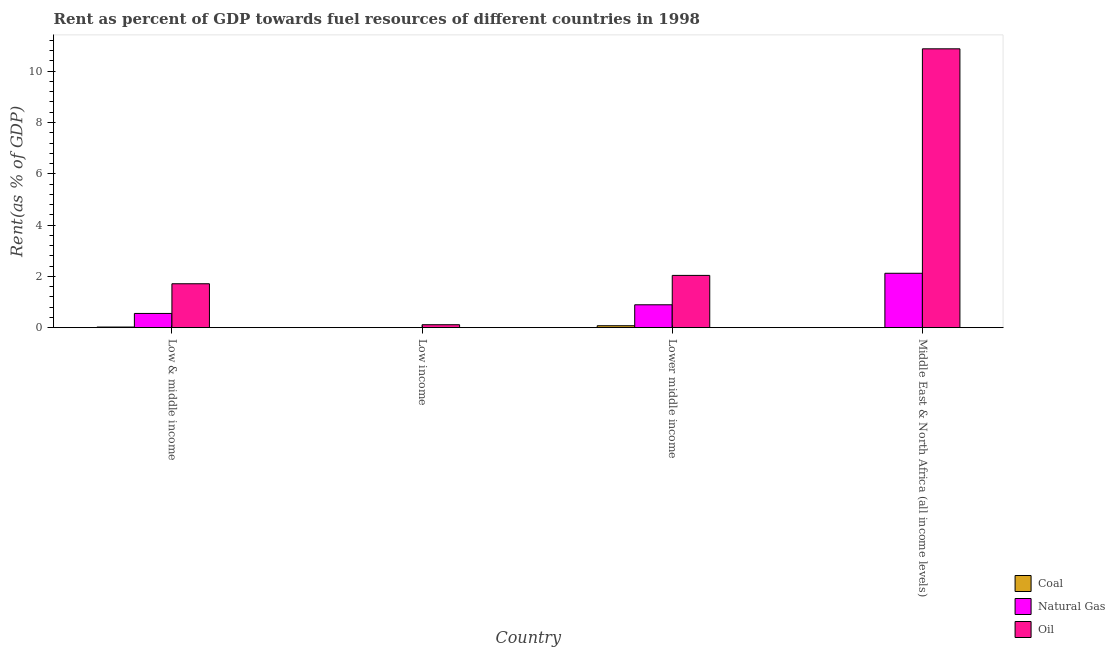How many groups of bars are there?
Your answer should be very brief. 4. How many bars are there on the 2nd tick from the left?
Your response must be concise. 3. How many bars are there on the 1st tick from the right?
Offer a terse response. 3. What is the label of the 1st group of bars from the left?
Provide a short and direct response. Low & middle income. What is the rent towards coal in Low income?
Your answer should be very brief. 3.540870127657071e-5. Across all countries, what is the maximum rent towards oil?
Ensure brevity in your answer.  10.87. Across all countries, what is the minimum rent towards natural gas?
Your response must be concise. 4.30567063288371e-5. In which country was the rent towards coal maximum?
Ensure brevity in your answer.  Lower middle income. What is the total rent towards natural gas in the graph?
Ensure brevity in your answer.  3.57. What is the difference between the rent towards oil in Low income and that in Middle East & North Africa (all income levels)?
Provide a succinct answer. -10.76. What is the difference between the rent towards natural gas in Low income and the rent towards coal in Low & middle income?
Your answer should be very brief. -0.02. What is the average rent towards natural gas per country?
Offer a very short reply. 0.89. What is the difference between the rent towards natural gas and rent towards oil in Middle East & North Africa (all income levels)?
Your response must be concise. -8.75. What is the ratio of the rent towards natural gas in Low & middle income to that in Low income?
Your response must be concise. 1.29e+04. Is the rent towards oil in Low income less than that in Lower middle income?
Your answer should be compact. Yes. Is the difference between the rent towards natural gas in Low & middle income and Low income greater than the difference between the rent towards coal in Low & middle income and Low income?
Ensure brevity in your answer.  Yes. What is the difference between the highest and the second highest rent towards natural gas?
Provide a short and direct response. 1.23. What is the difference between the highest and the lowest rent towards natural gas?
Provide a succinct answer. 2.12. What does the 2nd bar from the left in Lower middle income represents?
Ensure brevity in your answer.  Natural Gas. What does the 3rd bar from the right in Low income represents?
Give a very brief answer. Coal. Are the values on the major ticks of Y-axis written in scientific E-notation?
Your response must be concise. No. Does the graph contain any zero values?
Your answer should be very brief. No. Does the graph contain grids?
Give a very brief answer. No. Where does the legend appear in the graph?
Ensure brevity in your answer.  Bottom right. What is the title of the graph?
Your response must be concise. Rent as percent of GDP towards fuel resources of different countries in 1998. Does "Gaseous fuel" appear as one of the legend labels in the graph?
Ensure brevity in your answer.  No. What is the label or title of the Y-axis?
Offer a very short reply. Rent(as % of GDP). What is the Rent(as % of GDP) of Coal in Low & middle income?
Provide a short and direct response. 0.02. What is the Rent(as % of GDP) of Natural Gas in Low & middle income?
Provide a succinct answer. 0.55. What is the Rent(as % of GDP) in Oil in Low & middle income?
Ensure brevity in your answer.  1.71. What is the Rent(as % of GDP) in Coal in Low income?
Your response must be concise. 3.540870127657071e-5. What is the Rent(as % of GDP) in Natural Gas in Low income?
Your response must be concise. 4.30567063288371e-5. What is the Rent(as % of GDP) in Oil in Low income?
Give a very brief answer. 0.11. What is the Rent(as % of GDP) of Coal in Lower middle income?
Your answer should be compact. 0.08. What is the Rent(as % of GDP) of Natural Gas in Lower middle income?
Offer a very short reply. 0.89. What is the Rent(as % of GDP) in Oil in Lower middle income?
Give a very brief answer. 2.04. What is the Rent(as % of GDP) in Coal in Middle East & North Africa (all income levels)?
Give a very brief answer. 0. What is the Rent(as % of GDP) of Natural Gas in Middle East & North Africa (all income levels)?
Give a very brief answer. 2.12. What is the Rent(as % of GDP) of Oil in Middle East & North Africa (all income levels)?
Your answer should be compact. 10.87. Across all countries, what is the maximum Rent(as % of GDP) in Coal?
Your answer should be compact. 0.08. Across all countries, what is the maximum Rent(as % of GDP) in Natural Gas?
Offer a very short reply. 2.12. Across all countries, what is the maximum Rent(as % of GDP) in Oil?
Give a very brief answer. 10.87. Across all countries, what is the minimum Rent(as % of GDP) in Coal?
Your response must be concise. 3.540870127657071e-5. Across all countries, what is the minimum Rent(as % of GDP) in Natural Gas?
Your answer should be compact. 4.30567063288371e-5. Across all countries, what is the minimum Rent(as % of GDP) of Oil?
Give a very brief answer. 0.11. What is the total Rent(as % of GDP) in Coal in the graph?
Offer a very short reply. 0.1. What is the total Rent(as % of GDP) in Natural Gas in the graph?
Your answer should be compact. 3.57. What is the total Rent(as % of GDP) of Oil in the graph?
Offer a terse response. 14.74. What is the difference between the Rent(as % of GDP) in Coal in Low & middle income and that in Low income?
Offer a very short reply. 0.02. What is the difference between the Rent(as % of GDP) of Natural Gas in Low & middle income and that in Low income?
Your response must be concise. 0.55. What is the difference between the Rent(as % of GDP) of Oil in Low & middle income and that in Low income?
Your response must be concise. 1.6. What is the difference between the Rent(as % of GDP) of Coal in Low & middle income and that in Lower middle income?
Provide a succinct answer. -0.05. What is the difference between the Rent(as % of GDP) in Natural Gas in Low & middle income and that in Lower middle income?
Your answer should be very brief. -0.34. What is the difference between the Rent(as % of GDP) of Oil in Low & middle income and that in Lower middle income?
Make the answer very short. -0.33. What is the difference between the Rent(as % of GDP) in Coal in Low & middle income and that in Middle East & North Africa (all income levels)?
Make the answer very short. 0.02. What is the difference between the Rent(as % of GDP) in Natural Gas in Low & middle income and that in Middle East & North Africa (all income levels)?
Keep it short and to the point. -1.57. What is the difference between the Rent(as % of GDP) of Oil in Low & middle income and that in Middle East & North Africa (all income levels)?
Give a very brief answer. -9.16. What is the difference between the Rent(as % of GDP) of Coal in Low income and that in Lower middle income?
Offer a very short reply. -0.08. What is the difference between the Rent(as % of GDP) of Natural Gas in Low income and that in Lower middle income?
Your answer should be very brief. -0.89. What is the difference between the Rent(as % of GDP) of Oil in Low income and that in Lower middle income?
Make the answer very short. -1.92. What is the difference between the Rent(as % of GDP) in Coal in Low income and that in Middle East & North Africa (all income levels)?
Offer a terse response. -0. What is the difference between the Rent(as % of GDP) in Natural Gas in Low income and that in Middle East & North Africa (all income levels)?
Ensure brevity in your answer.  -2.12. What is the difference between the Rent(as % of GDP) in Oil in Low income and that in Middle East & North Africa (all income levels)?
Make the answer very short. -10.76. What is the difference between the Rent(as % of GDP) in Coal in Lower middle income and that in Middle East & North Africa (all income levels)?
Offer a very short reply. 0.07. What is the difference between the Rent(as % of GDP) of Natural Gas in Lower middle income and that in Middle East & North Africa (all income levels)?
Ensure brevity in your answer.  -1.23. What is the difference between the Rent(as % of GDP) of Oil in Lower middle income and that in Middle East & North Africa (all income levels)?
Ensure brevity in your answer.  -8.84. What is the difference between the Rent(as % of GDP) of Coal in Low & middle income and the Rent(as % of GDP) of Natural Gas in Low income?
Your answer should be very brief. 0.02. What is the difference between the Rent(as % of GDP) of Coal in Low & middle income and the Rent(as % of GDP) of Oil in Low income?
Provide a succinct answer. -0.09. What is the difference between the Rent(as % of GDP) in Natural Gas in Low & middle income and the Rent(as % of GDP) in Oil in Low income?
Your answer should be compact. 0.44. What is the difference between the Rent(as % of GDP) of Coal in Low & middle income and the Rent(as % of GDP) of Natural Gas in Lower middle income?
Give a very brief answer. -0.87. What is the difference between the Rent(as % of GDP) in Coal in Low & middle income and the Rent(as % of GDP) in Oil in Lower middle income?
Make the answer very short. -2.01. What is the difference between the Rent(as % of GDP) in Natural Gas in Low & middle income and the Rent(as % of GDP) in Oil in Lower middle income?
Offer a very short reply. -1.48. What is the difference between the Rent(as % of GDP) of Coal in Low & middle income and the Rent(as % of GDP) of Natural Gas in Middle East & North Africa (all income levels)?
Offer a terse response. -2.1. What is the difference between the Rent(as % of GDP) in Coal in Low & middle income and the Rent(as % of GDP) in Oil in Middle East & North Africa (all income levels)?
Offer a terse response. -10.85. What is the difference between the Rent(as % of GDP) in Natural Gas in Low & middle income and the Rent(as % of GDP) in Oil in Middle East & North Africa (all income levels)?
Your answer should be very brief. -10.32. What is the difference between the Rent(as % of GDP) of Coal in Low income and the Rent(as % of GDP) of Natural Gas in Lower middle income?
Ensure brevity in your answer.  -0.89. What is the difference between the Rent(as % of GDP) in Coal in Low income and the Rent(as % of GDP) in Oil in Lower middle income?
Your response must be concise. -2.04. What is the difference between the Rent(as % of GDP) in Natural Gas in Low income and the Rent(as % of GDP) in Oil in Lower middle income?
Offer a terse response. -2.04. What is the difference between the Rent(as % of GDP) in Coal in Low income and the Rent(as % of GDP) in Natural Gas in Middle East & North Africa (all income levels)?
Ensure brevity in your answer.  -2.12. What is the difference between the Rent(as % of GDP) of Coal in Low income and the Rent(as % of GDP) of Oil in Middle East & North Africa (all income levels)?
Your response must be concise. -10.87. What is the difference between the Rent(as % of GDP) of Natural Gas in Low income and the Rent(as % of GDP) of Oil in Middle East & North Africa (all income levels)?
Provide a short and direct response. -10.87. What is the difference between the Rent(as % of GDP) in Coal in Lower middle income and the Rent(as % of GDP) in Natural Gas in Middle East & North Africa (all income levels)?
Make the answer very short. -2.05. What is the difference between the Rent(as % of GDP) of Coal in Lower middle income and the Rent(as % of GDP) of Oil in Middle East & North Africa (all income levels)?
Provide a short and direct response. -10.8. What is the difference between the Rent(as % of GDP) in Natural Gas in Lower middle income and the Rent(as % of GDP) in Oil in Middle East & North Africa (all income levels)?
Your answer should be compact. -9.98. What is the average Rent(as % of GDP) in Coal per country?
Keep it short and to the point. 0.03. What is the average Rent(as % of GDP) in Natural Gas per country?
Offer a very short reply. 0.89. What is the average Rent(as % of GDP) of Oil per country?
Offer a very short reply. 3.68. What is the difference between the Rent(as % of GDP) of Coal and Rent(as % of GDP) of Natural Gas in Low & middle income?
Keep it short and to the point. -0.53. What is the difference between the Rent(as % of GDP) of Coal and Rent(as % of GDP) of Oil in Low & middle income?
Give a very brief answer. -1.69. What is the difference between the Rent(as % of GDP) in Natural Gas and Rent(as % of GDP) in Oil in Low & middle income?
Provide a succinct answer. -1.16. What is the difference between the Rent(as % of GDP) of Coal and Rent(as % of GDP) of Oil in Low income?
Offer a terse response. -0.11. What is the difference between the Rent(as % of GDP) in Natural Gas and Rent(as % of GDP) in Oil in Low income?
Ensure brevity in your answer.  -0.11. What is the difference between the Rent(as % of GDP) in Coal and Rent(as % of GDP) in Natural Gas in Lower middle income?
Your answer should be compact. -0.82. What is the difference between the Rent(as % of GDP) in Coal and Rent(as % of GDP) in Oil in Lower middle income?
Give a very brief answer. -1.96. What is the difference between the Rent(as % of GDP) in Natural Gas and Rent(as % of GDP) in Oil in Lower middle income?
Offer a very short reply. -1.15. What is the difference between the Rent(as % of GDP) of Coal and Rent(as % of GDP) of Natural Gas in Middle East & North Africa (all income levels)?
Your response must be concise. -2.12. What is the difference between the Rent(as % of GDP) of Coal and Rent(as % of GDP) of Oil in Middle East & North Africa (all income levels)?
Your response must be concise. -10.87. What is the difference between the Rent(as % of GDP) in Natural Gas and Rent(as % of GDP) in Oil in Middle East & North Africa (all income levels)?
Keep it short and to the point. -8.75. What is the ratio of the Rent(as % of GDP) in Coal in Low & middle income to that in Low income?
Your response must be concise. 690.86. What is the ratio of the Rent(as % of GDP) in Natural Gas in Low & middle income to that in Low income?
Offer a terse response. 1.29e+04. What is the ratio of the Rent(as % of GDP) in Oil in Low & middle income to that in Low income?
Give a very brief answer. 14.92. What is the ratio of the Rent(as % of GDP) in Coal in Low & middle income to that in Lower middle income?
Give a very brief answer. 0.32. What is the ratio of the Rent(as % of GDP) of Natural Gas in Low & middle income to that in Lower middle income?
Give a very brief answer. 0.62. What is the ratio of the Rent(as % of GDP) in Oil in Low & middle income to that in Lower middle income?
Make the answer very short. 0.84. What is the ratio of the Rent(as % of GDP) of Coal in Low & middle income to that in Middle East & North Africa (all income levels)?
Your response must be concise. 48.93. What is the ratio of the Rent(as % of GDP) of Natural Gas in Low & middle income to that in Middle East & North Africa (all income levels)?
Your answer should be very brief. 0.26. What is the ratio of the Rent(as % of GDP) of Oil in Low & middle income to that in Middle East & North Africa (all income levels)?
Keep it short and to the point. 0.16. What is the ratio of the Rent(as % of GDP) of Natural Gas in Low income to that in Lower middle income?
Your answer should be compact. 0. What is the ratio of the Rent(as % of GDP) of Oil in Low income to that in Lower middle income?
Give a very brief answer. 0.06. What is the ratio of the Rent(as % of GDP) in Coal in Low income to that in Middle East & North Africa (all income levels)?
Give a very brief answer. 0.07. What is the ratio of the Rent(as % of GDP) of Natural Gas in Low income to that in Middle East & North Africa (all income levels)?
Give a very brief answer. 0. What is the ratio of the Rent(as % of GDP) in Oil in Low income to that in Middle East & North Africa (all income levels)?
Keep it short and to the point. 0.01. What is the ratio of the Rent(as % of GDP) of Coal in Lower middle income to that in Middle East & North Africa (all income levels)?
Offer a very short reply. 150.63. What is the ratio of the Rent(as % of GDP) in Natural Gas in Lower middle income to that in Middle East & North Africa (all income levels)?
Offer a very short reply. 0.42. What is the ratio of the Rent(as % of GDP) of Oil in Lower middle income to that in Middle East & North Africa (all income levels)?
Your answer should be compact. 0.19. What is the difference between the highest and the second highest Rent(as % of GDP) of Coal?
Make the answer very short. 0.05. What is the difference between the highest and the second highest Rent(as % of GDP) of Natural Gas?
Offer a terse response. 1.23. What is the difference between the highest and the second highest Rent(as % of GDP) of Oil?
Your answer should be very brief. 8.84. What is the difference between the highest and the lowest Rent(as % of GDP) in Coal?
Your answer should be very brief. 0.08. What is the difference between the highest and the lowest Rent(as % of GDP) in Natural Gas?
Make the answer very short. 2.12. What is the difference between the highest and the lowest Rent(as % of GDP) in Oil?
Provide a succinct answer. 10.76. 